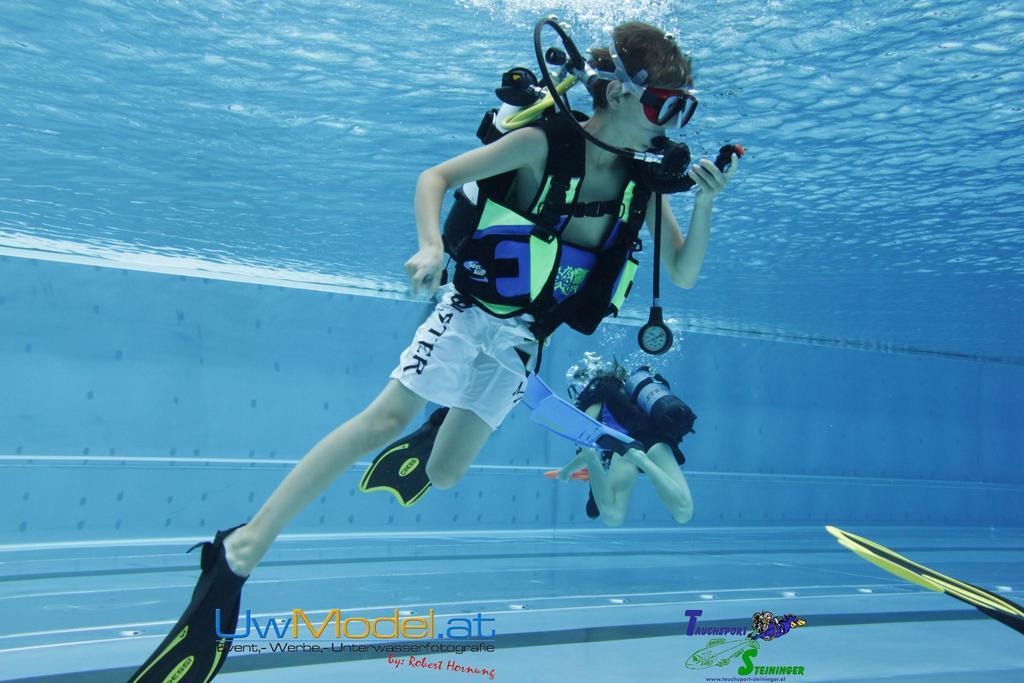In one or two sentences, can you explain what this image depicts? In a given image I can see a water, people, buoyancy compensator. 